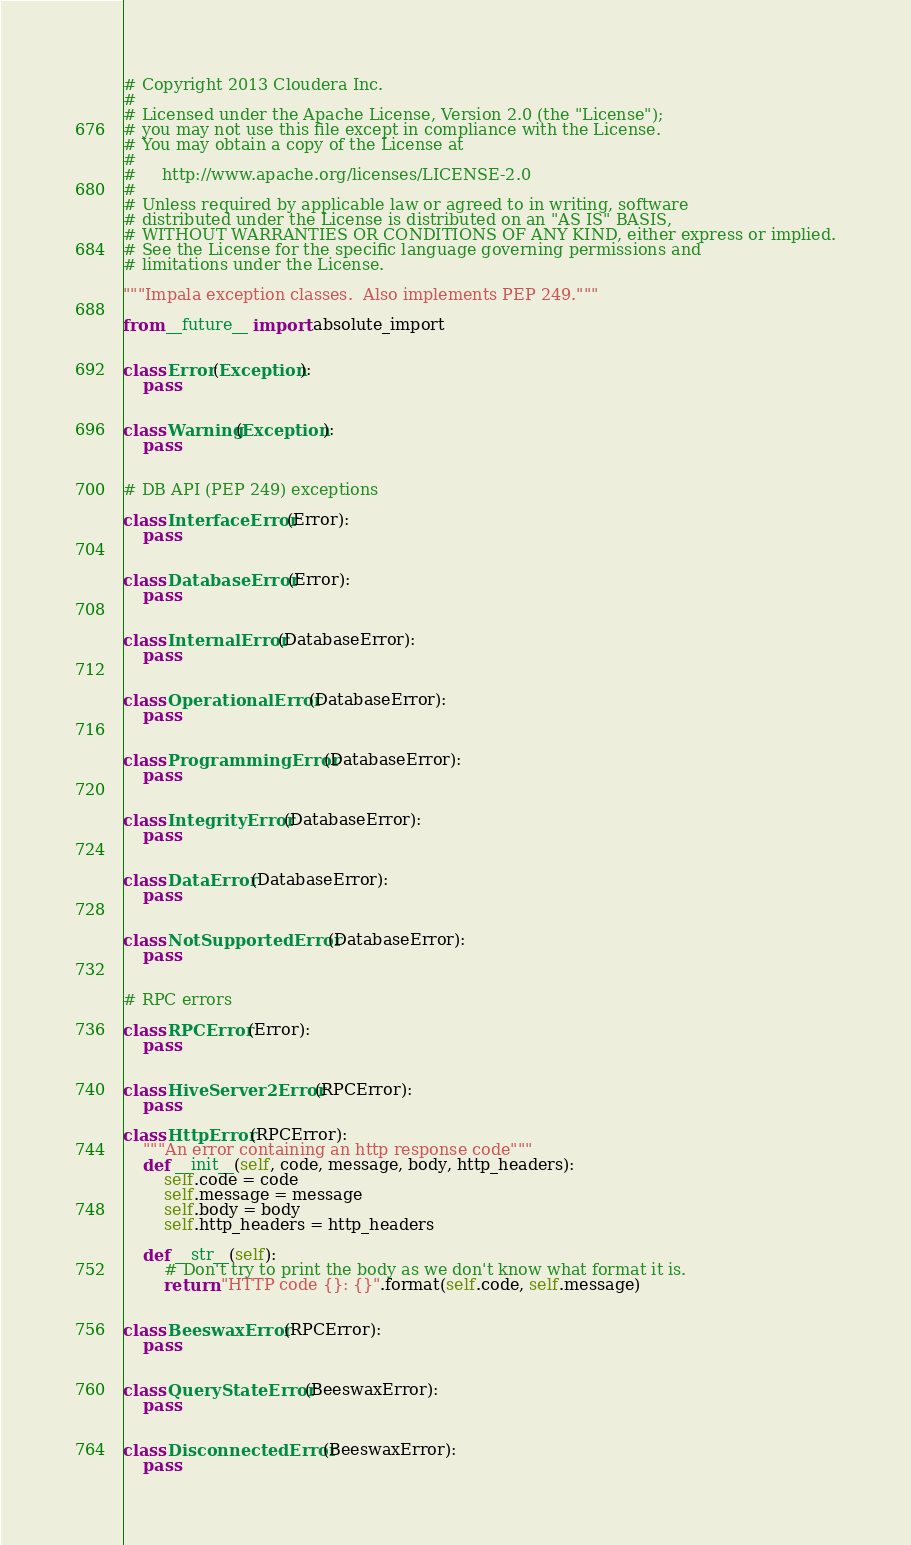Convert code to text. <code><loc_0><loc_0><loc_500><loc_500><_Python_># Copyright 2013 Cloudera Inc.
#
# Licensed under the Apache License, Version 2.0 (the "License");
# you may not use this file except in compliance with the License.
# You may obtain a copy of the License at
#
#     http://www.apache.org/licenses/LICENSE-2.0
#
# Unless required by applicable law or agreed to in writing, software
# distributed under the License is distributed on an "AS IS" BASIS,
# WITHOUT WARRANTIES OR CONDITIONS OF ANY KIND, either express or implied.
# See the License for the specific language governing permissions and
# limitations under the License.

"""Impala exception classes.  Also implements PEP 249."""

from __future__ import absolute_import


class Error(Exception):
    pass


class Warning(Exception):
    pass


# DB API (PEP 249) exceptions

class InterfaceError(Error):
    pass


class DatabaseError(Error):
    pass


class InternalError(DatabaseError):
    pass


class OperationalError(DatabaseError):
    pass


class ProgrammingError(DatabaseError):
    pass


class IntegrityError(DatabaseError):
    pass


class DataError(DatabaseError):
    pass


class NotSupportedError(DatabaseError):
    pass


# RPC errors

class RPCError(Error):
    pass


class HiveServer2Error(RPCError):
    pass

class HttpError(RPCError):
    """An error containing an http response code"""
    def __init__(self, code, message, body, http_headers):
        self.code = code
        self.message = message
        self.body = body
        self.http_headers = http_headers

    def __str__(self):
        # Don't try to print the body as we don't know what format it is.
        return "HTTP code {}: {}".format(self.code, self.message)


class BeeswaxError(RPCError):
    pass


class QueryStateError(BeeswaxError):
    pass


class DisconnectedError(BeeswaxError):
    pass
</code> 